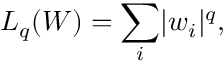<formula> <loc_0><loc_0><loc_500><loc_500>L _ { q } ( W ) = \sum _ { i } | w _ { i } | ^ { q } ,</formula> 